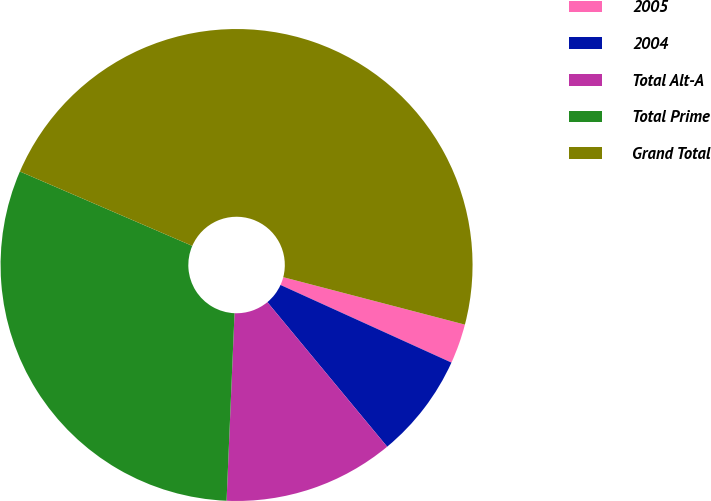Convert chart. <chart><loc_0><loc_0><loc_500><loc_500><pie_chart><fcel>2005<fcel>2004<fcel>Total Alt-A<fcel>Total Prime<fcel>Grand Total<nl><fcel>2.72%<fcel>7.2%<fcel>11.69%<fcel>30.81%<fcel>47.58%<nl></chart> 